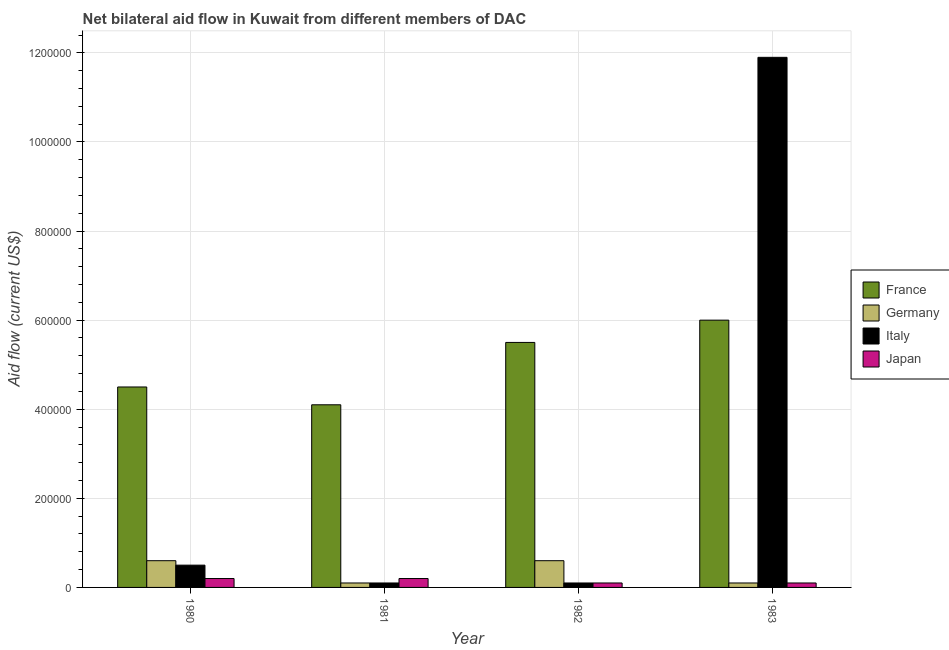How many groups of bars are there?
Give a very brief answer. 4. Are the number of bars per tick equal to the number of legend labels?
Offer a terse response. Yes. Are the number of bars on each tick of the X-axis equal?
Your response must be concise. Yes. How many bars are there on the 4th tick from the left?
Your answer should be very brief. 4. How many bars are there on the 4th tick from the right?
Ensure brevity in your answer.  4. In how many cases, is the number of bars for a given year not equal to the number of legend labels?
Your response must be concise. 0. What is the amount of aid given by japan in 1983?
Your answer should be compact. 10000. Across all years, what is the maximum amount of aid given by japan?
Make the answer very short. 2.00e+04. Across all years, what is the minimum amount of aid given by italy?
Provide a succinct answer. 10000. In which year was the amount of aid given by france maximum?
Offer a very short reply. 1983. In which year was the amount of aid given by japan minimum?
Offer a very short reply. 1982. What is the total amount of aid given by france in the graph?
Keep it short and to the point. 2.01e+06. What is the difference between the amount of aid given by italy in 1981 and that in 1982?
Provide a short and direct response. 0. What is the difference between the amount of aid given by germany in 1981 and the amount of aid given by italy in 1983?
Keep it short and to the point. 0. What is the average amount of aid given by japan per year?
Provide a short and direct response. 1.50e+04. What is the ratio of the amount of aid given by germany in 1981 to that in 1983?
Your answer should be compact. 1. Is the difference between the amount of aid given by japan in 1981 and 1982 greater than the difference between the amount of aid given by germany in 1981 and 1982?
Keep it short and to the point. No. What is the difference between the highest and the second highest amount of aid given by france?
Your answer should be very brief. 5.00e+04. What is the difference between the highest and the lowest amount of aid given by germany?
Your answer should be compact. 5.00e+04. In how many years, is the amount of aid given by france greater than the average amount of aid given by france taken over all years?
Ensure brevity in your answer.  2. Is the sum of the amount of aid given by germany in 1980 and 1982 greater than the maximum amount of aid given by italy across all years?
Your answer should be very brief. Yes. How many bars are there?
Offer a terse response. 16. Are the values on the major ticks of Y-axis written in scientific E-notation?
Your response must be concise. No. Does the graph contain grids?
Your answer should be compact. Yes. What is the title of the graph?
Your answer should be compact. Net bilateral aid flow in Kuwait from different members of DAC. Does "Japan" appear as one of the legend labels in the graph?
Your response must be concise. Yes. What is the label or title of the X-axis?
Offer a terse response. Year. What is the label or title of the Y-axis?
Provide a short and direct response. Aid flow (current US$). What is the Aid flow (current US$) of France in 1980?
Offer a terse response. 4.50e+05. What is the Aid flow (current US$) of Italy in 1980?
Offer a terse response. 5.00e+04. What is the Aid flow (current US$) of Japan in 1980?
Give a very brief answer. 2.00e+04. What is the Aid flow (current US$) in France in 1981?
Your response must be concise. 4.10e+05. What is the Aid flow (current US$) in Germany in 1981?
Your response must be concise. 10000. What is the Aid flow (current US$) in Italy in 1981?
Your answer should be compact. 10000. What is the Aid flow (current US$) of Japan in 1981?
Your answer should be very brief. 2.00e+04. What is the Aid flow (current US$) of Italy in 1982?
Make the answer very short. 10000. What is the Aid flow (current US$) in Japan in 1982?
Your answer should be compact. 10000. What is the Aid flow (current US$) of Germany in 1983?
Give a very brief answer. 10000. What is the Aid flow (current US$) in Italy in 1983?
Your answer should be very brief. 1.19e+06. Across all years, what is the maximum Aid flow (current US$) in Italy?
Provide a short and direct response. 1.19e+06. Across all years, what is the minimum Aid flow (current US$) of France?
Offer a very short reply. 4.10e+05. Across all years, what is the minimum Aid flow (current US$) of Germany?
Your response must be concise. 10000. What is the total Aid flow (current US$) of France in the graph?
Your response must be concise. 2.01e+06. What is the total Aid flow (current US$) of Germany in the graph?
Ensure brevity in your answer.  1.40e+05. What is the total Aid flow (current US$) of Italy in the graph?
Offer a very short reply. 1.26e+06. What is the difference between the Aid flow (current US$) of France in 1980 and that in 1981?
Your answer should be compact. 4.00e+04. What is the difference between the Aid flow (current US$) of Germany in 1980 and that in 1981?
Keep it short and to the point. 5.00e+04. What is the difference between the Aid flow (current US$) in Italy in 1980 and that in 1981?
Give a very brief answer. 4.00e+04. What is the difference between the Aid flow (current US$) in France in 1980 and that in 1982?
Make the answer very short. -1.00e+05. What is the difference between the Aid flow (current US$) in Germany in 1980 and that in 1982?
Your response must be concise. 0. What is the difference between the Aid flow (current US$) in Italy in 1980 and that in 1982?
Offer a very short reply. 4.00e+04. What is the difference between the Aid flow (current US$) of France in 1980 and that in 1983?
Provide a short and direct response. -1.50e+05. What is the difference between the Aid flow (current US$) in Germany in 1980 and that in 1983?
Keep it short and to the point. 5.00e+04. What is the difference between the Aid flow (current US$) of Italy in 1980 and that in 1983?
Provide a succinct answer. -1.14e+06. What is the difference between the Aid flow (current US$) of Japan in 1980 and that in 1983?
Provide a short and direct response. 10000. What is the difference between the Aid flow (current US$) of France in 1981 and that in 1982?
Make the answer very short. -1.40e+05. What is the difference between the Aid flow (current US$) of Germany in 1981 and that in 1982?
Keep it short and to the point. -5.00e+04. What is the difference between the Aid flow (current US$) of Italy in 1981 and that in 1982?
Offer a terse response. 0. What is the difference between the Aid flow (current US$) in Italy in 1981 and that in 1983?
Offer a terse response. -1.18e+06. What is the difference between the Aid flow (current US$) in Japan in 1981 and that in 1983?
Keep it short and to the point. 10000. What is the difference between the Aid flow (current US$) of Italy in 1982 and that in 1983?
Your answer should be compact. -1.18e+06. What is the difference between the Aid flow (current US$) in Japan in 1982 and that in 1983?
Offer a very short reply. 0. What is the difference between the Aid flow (current US$) in France in 1980 and the Aid flow (current US$) in Italy in 1981?
Keep it short and to the point. 4.40e+05. What is the difference between the Aid flow (current US$) in Germany in 1980 and the Aid flow (current US$) in Japan in 1981?
Make the answer very short. 4.00e+04. What is the difference between the Aid flow (current US$) of France in 1980 and the Aid flow (current US$) of Japan in 1982?
Provide a short and direct response. 4.40e+05. What is the difference between the Aid flow (current US$) of Italy in 1980 and the Aid flow (current US$) of Japan in 1982?
Offer a very short reply. 4.00e+04. What is the difference between the Aid flow (current US$) of France in 1980 and the Aid flow (current US$) of Germany in 1983?
Provide a short and direct response. 4.40e+05. What is the difference between the Aid flow (current US$) in France in 1980 and the Aid flow (current US$) in Italy in 1983?
Provide a short and direct response. -7.40e+05. What is the difference between the Aid flow (current US$) of Germany in 1980 and the Aid flow (current US$) of Italy in 1983?
Make the answer very short. -1.13e+06. What is the difference between the Aid flow (current US$) in Germany in 1980 and the Aid flow (current US$) in Japan in 1983?
Make the answer very short. 5.00e+04. What is the difference between the Aid flow (current US$) in Italy in 1980 and the Aid flow (current US$) in Japan in 1983?
Provide a short and direct response. 4.00e+04. What is the difference between the Aid flow (current US$) in France in 1981 and the Aid flow (current US$) in Germany in 1982?
Provide a short and direct response. 3.50e+05. What is the difference between the Aid flow (current US$) in Germany in 1981 and the Aid flow (current US$) in Italy in 1982?
Offer a terse response. 0. What is the difference between the Aid flow (current US$) in Germany in 1981 and the Aid flow (current US$) in Japan in 1982?
Make the answer very short. 0. What is the difference between the Aid flow (current US$) in France in 1981 and the Aid flow (current US$) in Germany in 1983?
Provide a succinct answer. 4.00e+05. What is the difference between the Aid flow (current US$) in France in 1981 and the Aid flow (current US$) in Italy in 1983?
Your answer should be compact. -7.80e+05. What is the difference between the Aid flow (current US$) of Germany in 1981 and the Aid flow (current US$) of Italy in 1983?
Offer a very short reply. -1.18e+06. What is the difference between the Aid flow (current US$) in Germany in 1981 and the Aid flow (current US$) in Japan in 1983?
Offer a very short reply. 0. What is the difference between the Aid flow (current US$) in Italy in 1981 and the Aid flow (current US$) in Japan in 1983?
Keep it short and to the point. 0. What is the difference between the Aid flow (current US$) in France in 1982 and the Aid flow (current US$) in Germany in 1983?
Provide a succinct answer. 5.40e+05. What is the difference between the Aid flow (current US$) in France in 1982 and the Aid flow (current US$) in Italy in 1983?
Provide a succinct answer. -6.40e+05. What is the difference between the Aid flow (current US$) of France in 1982 and the Aid flow (current US$) of Japan in 1983?
Keep it short and to the point. 5.40e+05. What is the difference between the Aid flow (current US$) in Germany in 1982 and the Aid flow (current US$) in Italy in 1983?
Ensure brevity in your answer.  -1.13e+06. What is the difference between the Aid flow (current US$) in Italy in 1982 and the Aid flow (current US$) in Japan in 1983?
Give a very brief answer. 0. What is the average Aid flow (current US$) in France per year?
Offer a terse response. 5.02e+05. What is the average Aid flow (current US$) in Germany per year?
Make the answer very short. 3.50e+04. What is the average Aid flow (current US$) in Italy per year?
Offer a very short reply. 3.15e+05. What is the average Aid flow (current US$) in Japan per year?
Ensure brevity in your answer.  1.50e+04. In the year 1980, what is the difference between the Aid flow (current US$) in France and Aid flow (current US$) in Germany?
Ensure brevity in your answer.  3.90e+05. In the year 1980, what is the difference between the Aid flow (current US$) of France and Aid flow (current US$) of Italy?
Provide a short and direct response. 4.00e+05. In the year 1980, what is the difference between the Aid flow (current US$) of France and Aid flow (current US$) of Japan?
Give a very brief answer. 4.30e+05. In the year 1980, what is the difference between the Aid flow (current US$) of Germany and Aid flow (current US$) of Italy?
Your answer should be very brief. 10000. In the year 1980, what is the difference between the Aid flow (current US$) in Germany and Aid flow (current US$) in Japan?
Offer a very short reply. 4.00e+04. In the year 1980, what is the difference between the Aid flow (current US$) in Italy and Aid flow (current US$) in Japan?
Provide a succinct answer. 3.00e+04. In the year 1981, what is the difference between the Aid flow (current US$) of France and Aid flow (current US$) of Germany?
Offer a terse response. 4.00e+05. In the year 1981, what is the difference between the Aid flow (current US$) of France and Aid flow (current US$) of Italy?
Your response must be concise. 4.00e+05. In the year 1981, what is the difference between the Aid flow (current US$) in Germany and Aid flow (current US$) in Italy?
Keep it short and to the point. 0. In the year 1982, what is the difference between the Aid flow (current US$) of France and Aid flow (current US$) of Italy?
Offer a very short reply. 5.40e+05. In the year 1982, what is the difference between the Aid flow (current US$) of France and Aid flow (current US$) of Japan?
Offer a very short reply. 5.40e+05. In the year 1982, what is the difference between the Aid flow (current US$) in Germany and Aid flow (current US$) in Japan?
Provide a succinct answer. 5.00e+04. In the year 1982, what is the difference between the Aid flow (current US$) of Italy and Aid flow (current US$) of Japan?
Give a very brief answer. 0. In the year 1983, what is the difference between the Aid flow (current US$) of France and Aid flow (current US$) of Germany?
Your response must be concise. 5.90e+05. In the year 1983, what is the difference between the Aid flow (current US$) in France and Aid flow (current US$) in Italy?
Offer a terse response. -5.90e+05. In the year 1983, what is the difference between the Aid flow (current US$) in France and Aid flow (current US$) in Japan?
Your response must be concise. 5.90e+05. In the year 1983, what is the difference between the Aid flow (current US$) in Germany and Aid flow (current US$) in Italy?
Your answer should be very brief. -1.18e+06. In the year 1983, what is the difference between the Aid flow (current US$) of Italy and Aid flow (current US$) of Japan?
Offer a terse response. 1.18e+06. What is the ratio of the Aid flow (current US$) in France in 1980 to that in 1981?
Keep it short and to the point. 1.1. What is the ratio of the Aid flow (current US$) of Italy in 1980 to that in 1981?
Provide a short and direct response. 5. What is the ratio of the Aid flow (current US$) of France in 1980 to that in 1982?
Make the answer very short. 0.82. What is the ratio of the Aid flow (current US$) of Japan in 1980 to that in 1982?
Ensure brevity in your answer.  2. What is the ratio of the Aid flow (current US$) in France in 1980 to that in 1983?
Provide a short and direct response. 0.75. What is the ratio of the Aid flow (current US$) of Germany in 1980 to that in 1983?
Make the answer very short. 6. What is the ratio of the Aid flow (current US$) of Italy in 1980 to that in 1983?
Offer a terse response. 0.04. What is the ratio of the Aid flow (current US$) of Japan in 1980 to that in 1983?
Provide a succinct answer. 2. What is the ratio of the Aid flow (current US$) of France in 1981 to that in 1982?
Your answer should be very brief. 0.75. What is the ratio of the Aid flow (current US$) in Italy in 1981 to that in 1982?
Make the answer very short. 1. What is the ratio of the Aid flow (current US$) of France in 1981 to that in 1983?
Your response must be concise. 0.68. What is the ratio of the Aid flow (current US$) of Italy in 1981 to that in 1983?
Provide a short and direct response. 0.01. What is the ratio of the Aid flow (current US$) in Italy in 1982 to that in 1983?
Offer a terse response. 0.01. What is the ratio of the Aid flow (current US$) of Japan in 1982 to that in 1983?
Keep it short and to the point. 1. What is the difference between the highest and the second highest Aid flow (current US$) in France?
Provide a succinct answer. 5.00e+04. What is the difference between the highest and the second highest Aid flow (current US$) in Germany?
Provide a short and direct response. 0. What is the difference between the highest and the second highest Aid flow (current US$) of Italy?
Your response must be concise. 1.14e+06. What is the difference between the highest and the lowest Aid flow (current US$) in Italy?
Make the answer very short. 1.18e+06. What is the difference between the highest and the lowest Aid flow (current US$) of Japan?
Ensure brevity in your answer.  10000. 